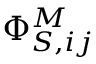Convert formula to latex. <formula><loc_0><loc_0><loc_500><loc_500>\Phi _ { S , i j } ^ { M }</formula> 